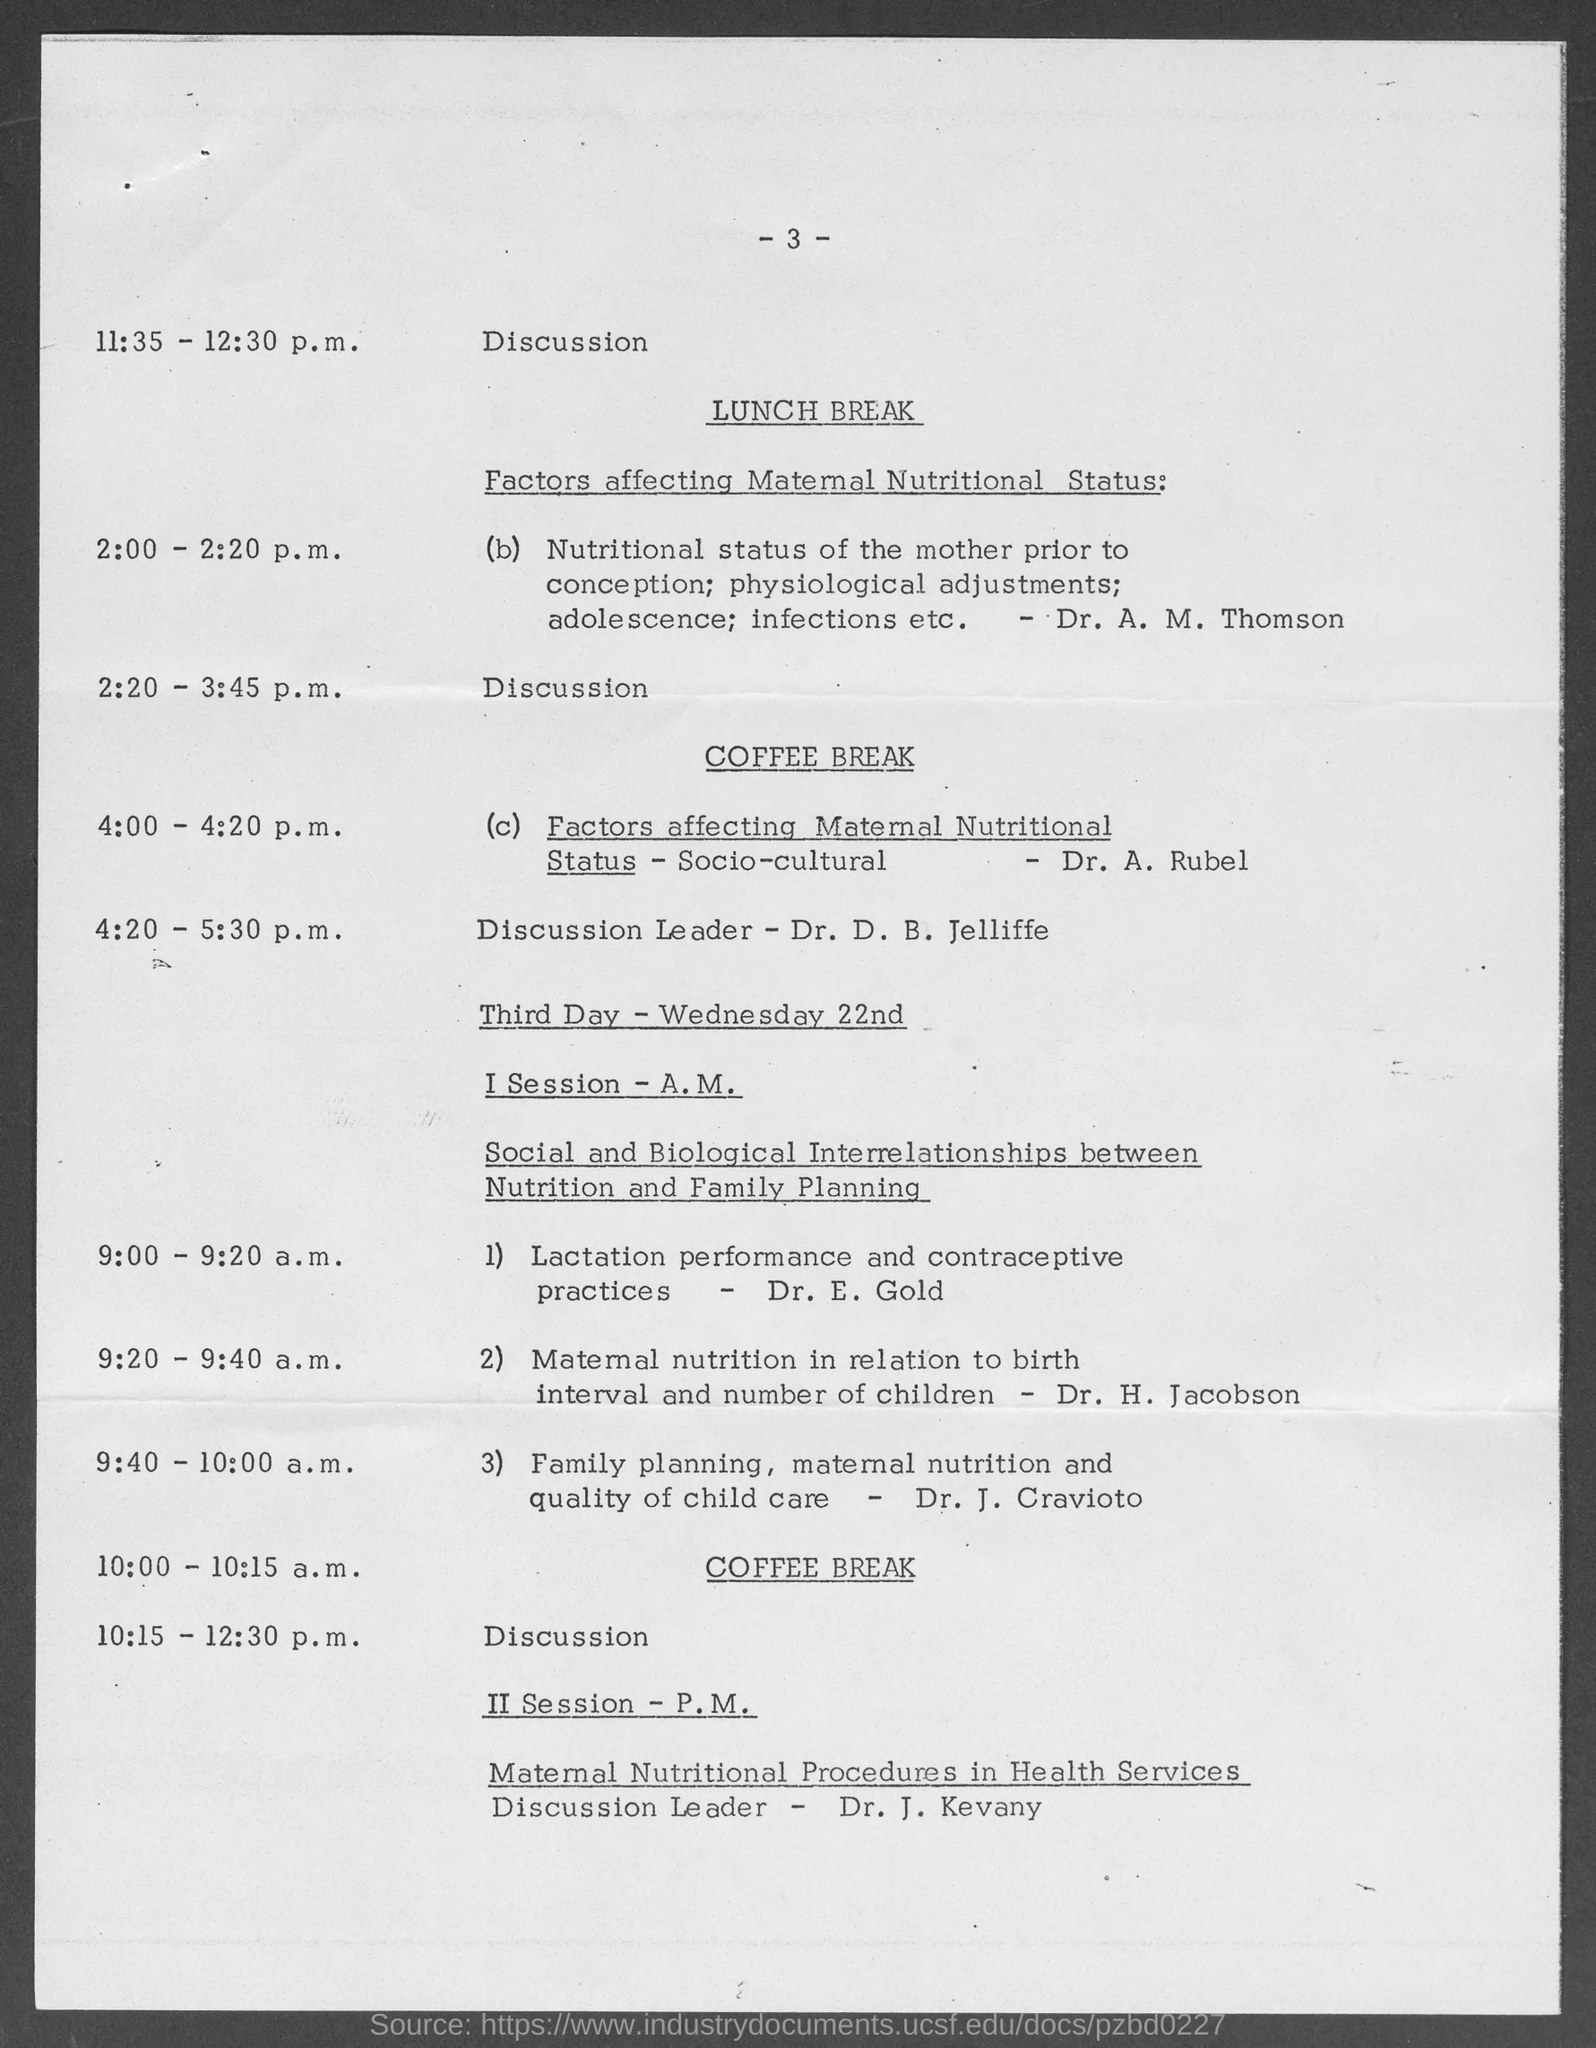Mention the page number which is written in top ?
Offer a terse response. -3-. Who conducted the paper on the topic "Nutritional Status of the mother prior to conception; physiological adjustments;adolescence;infections etc. " ?
Give a very brief answer. Dr. A. M. Thomson. When is the Third day ?
Keep it short and to the point. Wednesday 22nd. Who conducted the Paper on the topic "Lactation performance and contraceptive practices" ?
Offer a very short reply. Dr. E. Gold. Who is the discussion leader of the topic " Maternal nutritional procedures in health services" ?
Offer a very short reply. Dr. J. Kevany. Who conducted the Paper on the topic "Maternal nutrition in relation to birth interval and number of children " ?
Keep it short and to the point. DR. H. Jacobson. When is the coffee break ?
Keep it short and to the point. 10:00 - 10:15 a.m. When did Dr. D. B. jelliffe conduct his discussion ?
Provide a succinct answer. 4:20 - 5:30 p.m. 